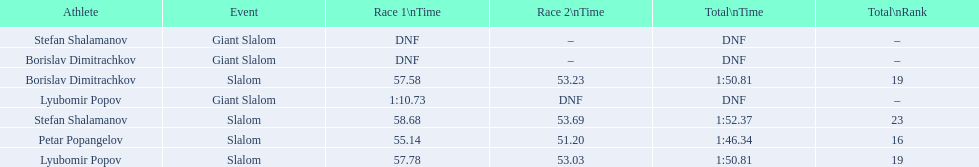What were the event names during bulgaria at the 1988 winter olympics? Stefan Shalamanov, Borislav Dimitrachkov, Lyubomir Popov. And which players participated at giant slalom? Giant Slalom, Giant Slalom, Giant Slalom, Slalom, Slalom, Slalom, Slalom. What were their race 1 times? DNF, DNF, 1:10.73. What was lyubomir popov's personal time? 1:10.73. 